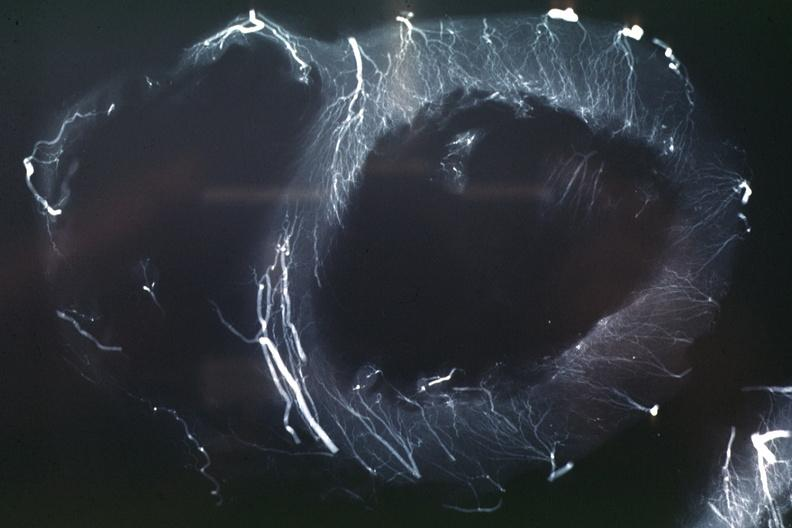what is present?
Answer the question using a single word or phrase. Cardiovascular 